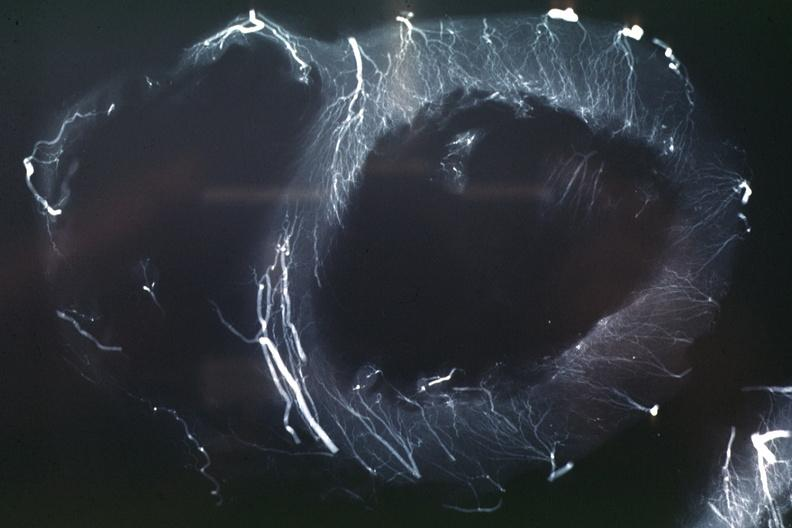what is present?
Answer the question using a single word or phrase. Cardiovascular 